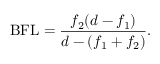<formula> <loc_0><loc_0><loc_500><loc_500>{ B F L } = { \frac { f _ { 2 } ( d - f _ { 1 } ) } { d - ( f _ { 1 } + f _ { 2 } ) } } .</formula> 